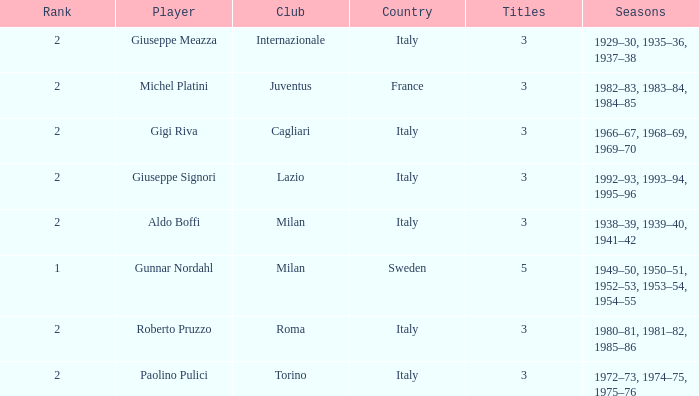How many rankings are associated with giuseppe meazza holding over 3 titles? 0.0. 